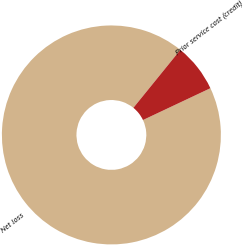Convert chart to OTSL. <chart><loc_0><loc_0><loc_500><loc_500><pie_chart><fcel>Net loss<fcel>Prior service cost (credit)<nl><fcel>92.86%<fcel>7.14%<nl></chart> 